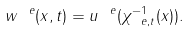<formula> <loc_0><loc_0><loc_500><loc_500>w ^ { \ e } ( x , t ) = u ^ { \ e } ( \chi ^ { - 1 } _ { \ e , t } ( x ) ) .</formula> 